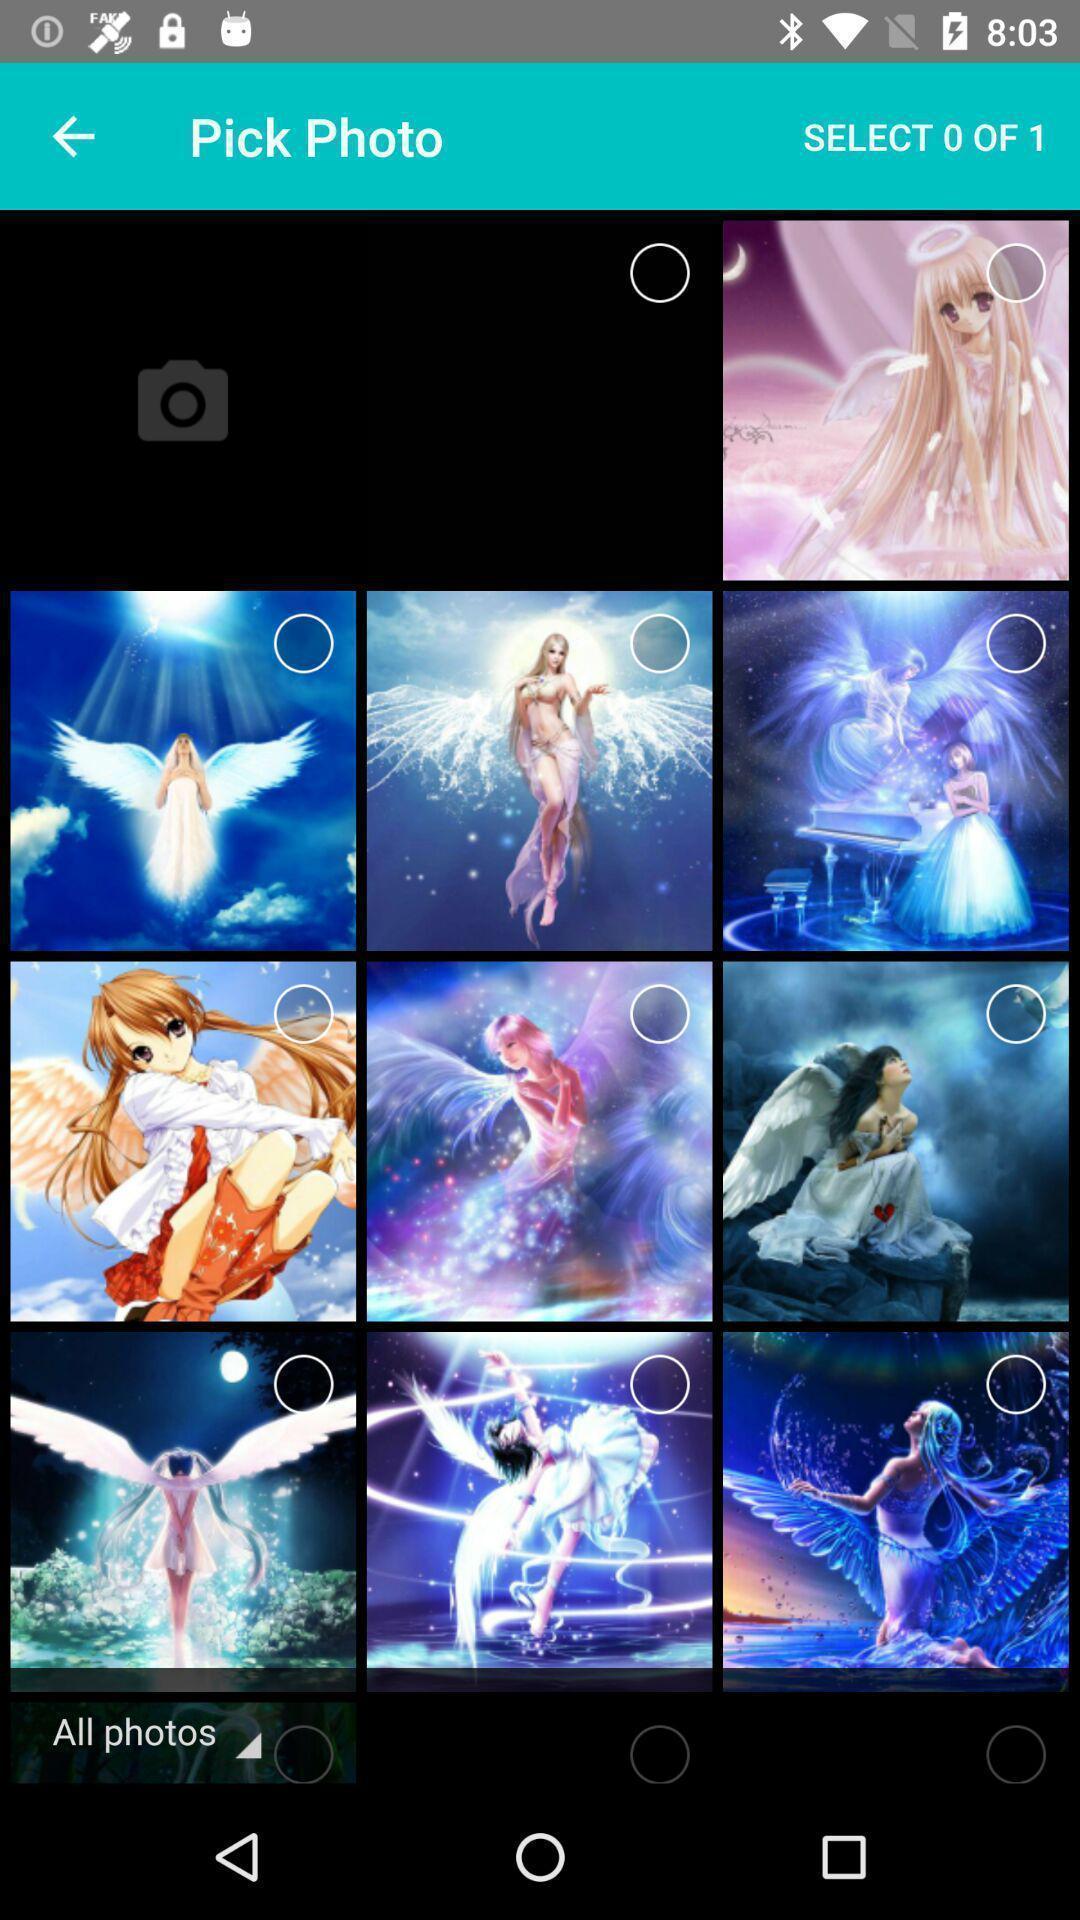Provide a textual representation of this image. Screen displaying multiple animated pictures in a gallery. 